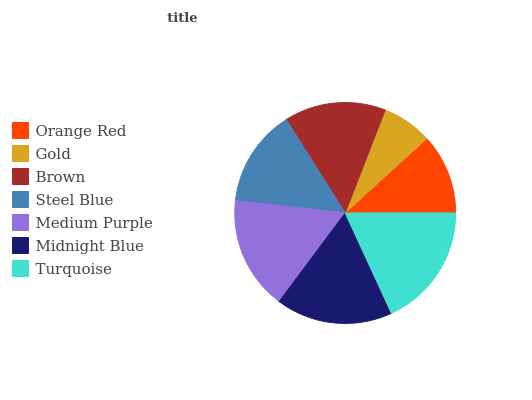Is Gold the minimum?
Answer yes or no. Yes. Is Turquoise the maximum?
Answer yes or no. Yes. Is Brown the minimum?
Answer yes or no. No. Is Brown the maximum?
Answer yes or no. No. Is Brown greater than Gold?
Answer yes or no. Yes. Is Gold less than Brown?
Answer yes or no. Yes. Is Gold greater than Brown?
Answer yes or no. No. Is Brown less than Gold?
Answer yes or no. No. Is Brown the high median?
Answer yes or no. Yes. Is Brown the low median?
Answer yes or no. Yes. Is Orange Red the high median?
Answer yes or no. No. Is Steel Blue the low median?
Answer yes or no. No. 